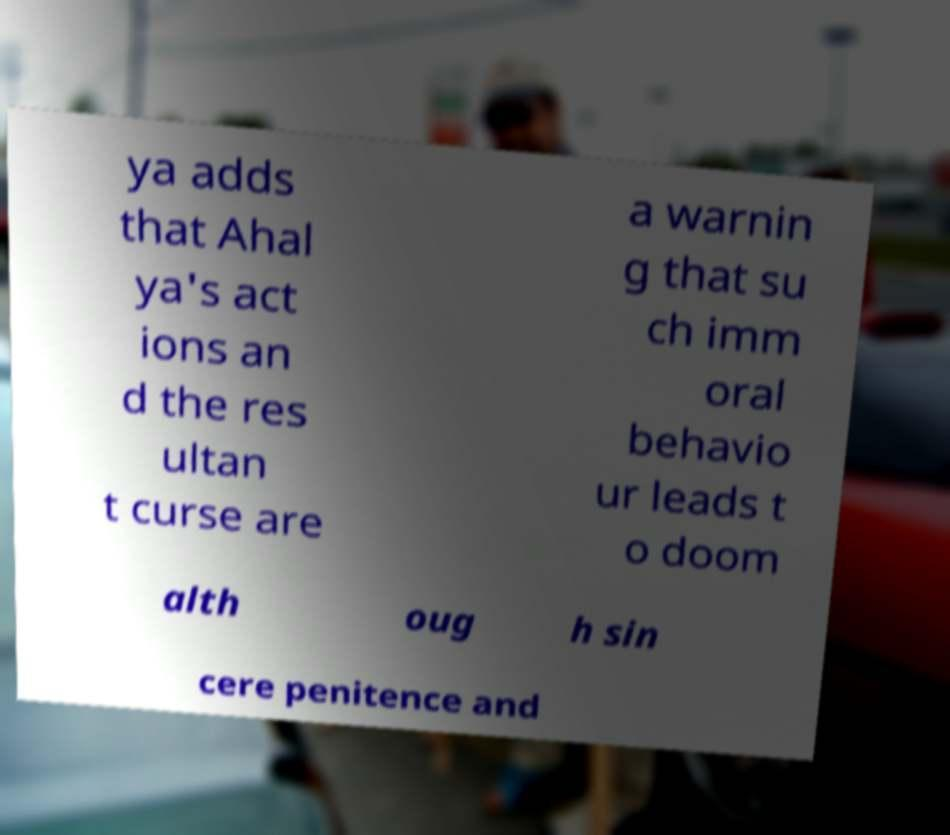Can you read and provide the text displayed in the image?This photo seems to have some interesting text. Can you extract and type it out for me? ya adds that Ahal ya's act ions an d the res ultan t curse are a warnin g that su ch imm oral behavio ur leads t o doom alth oug h sin cere penitence and 